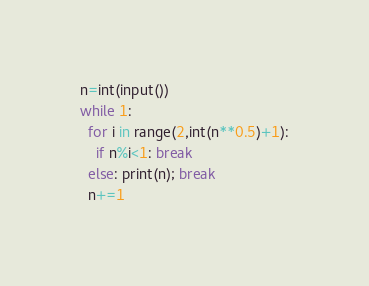Convert code to text. <code><loc_0><loc_0><loc_500><loc_500><_Python_>n=int(input())
while 1:
  for i in range(2,int(n**0.5)+1):
    if n%i<1: break
  else: print(n); break
  n+=1</code> 